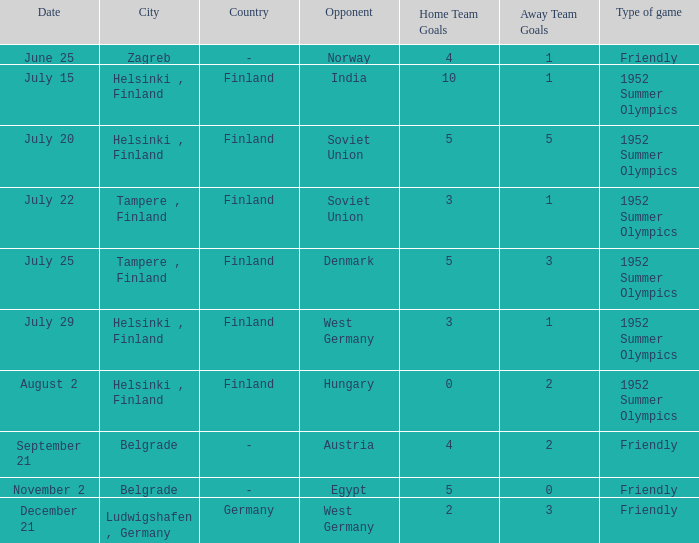What is the name of the City with December 21 as a Date? Ludwigshafen , Germany. 